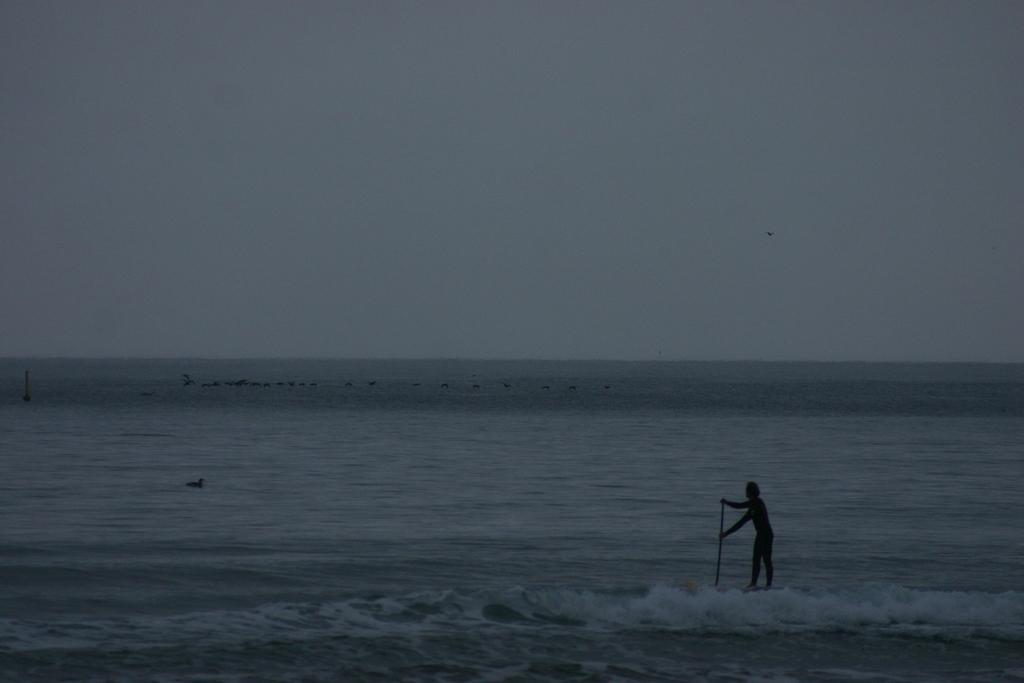Please provide a concise description of this image. In this image there is water at the bottom. There is a person holding an object in the foreground. There is water in the background. And there is sky at the top. 